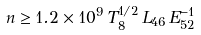Convert formula to latex. <formula><loc_0><loc_0><loc_500><loc_500>n \geq 1 . 2 \times 1 0 ^ { 9 } \, T _ { 8 } ^ { 1 / 2 } \, L _ { 4 6 } \, E _ { 5 2 } ^ { - 1 }</formula> 